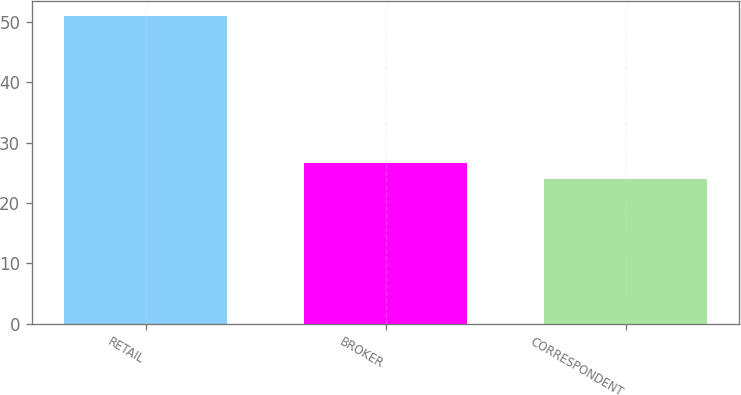Convert chart. <chart><loc_0><loc_0><loc_500><loc_500><bar_chart><fcel>RETAIL<fcel>BROKER<fcel>CORRESPONDENT<nl><fcel>51<fcel>26.7<fcel>24<nl></chart> 